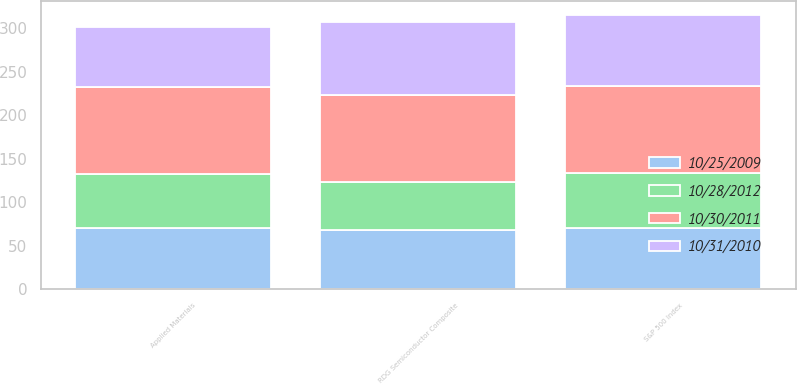Convert chart. <chart><loc_0><loc_0><loc_500><loc_500><stacked_bar_chart><ecel><fcel>Applied Materials<fcel>S&P 500 Index<fcel>RDG Semiconductor Composite<nl><fcel>10/30/2011<fcel>100<fcel>100<fcel>100<nl><fcel>10/28/2012<fcel>61.22<fcel>63.9<fcel>54.74<nl><fcel>10/25/2009<fcel>71.06<fcel>70.17<fcel>68.59<nl><fcel>10/31/2010<fcel>69.23<fcel>81.76<fcel>84.46<nl></chart> 